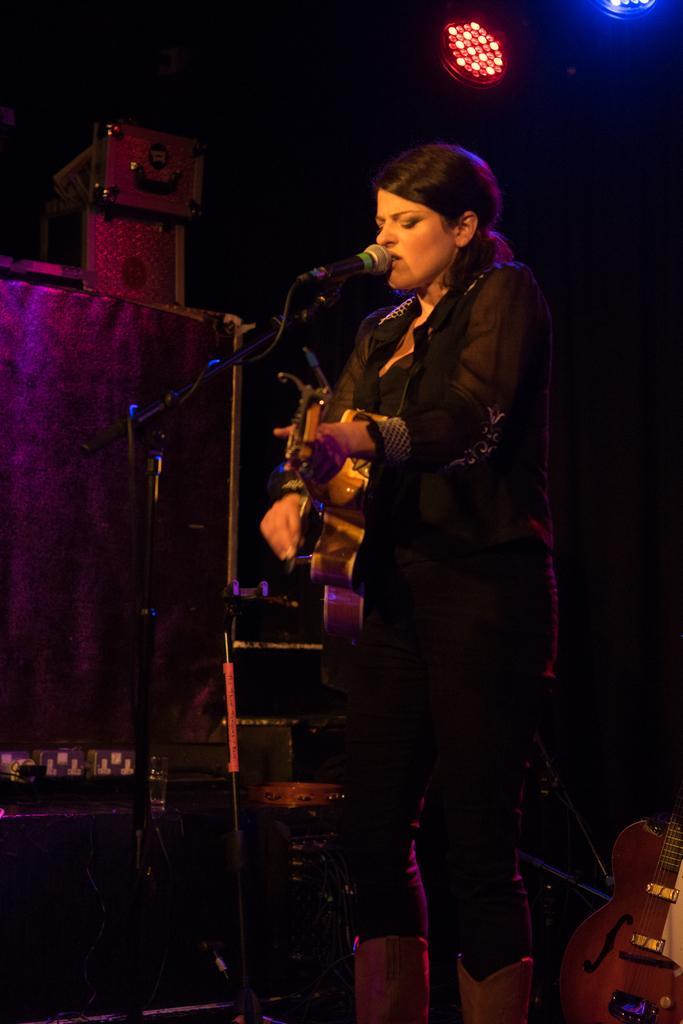Can you describe this image briefly? A lady in black dress is holding guitar and playing it and singing. A mic is in front of her. There are lights in the background. Also a guitar is on the floor. 